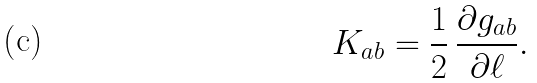Convert formula to latex. <formula><loc_0><loc_0><loc_500><loc_500>K _ { a b } = \frac { 1 } { 2 } \, \frac { \partial g _ { a b } } { \partial \ell } .</formula> 